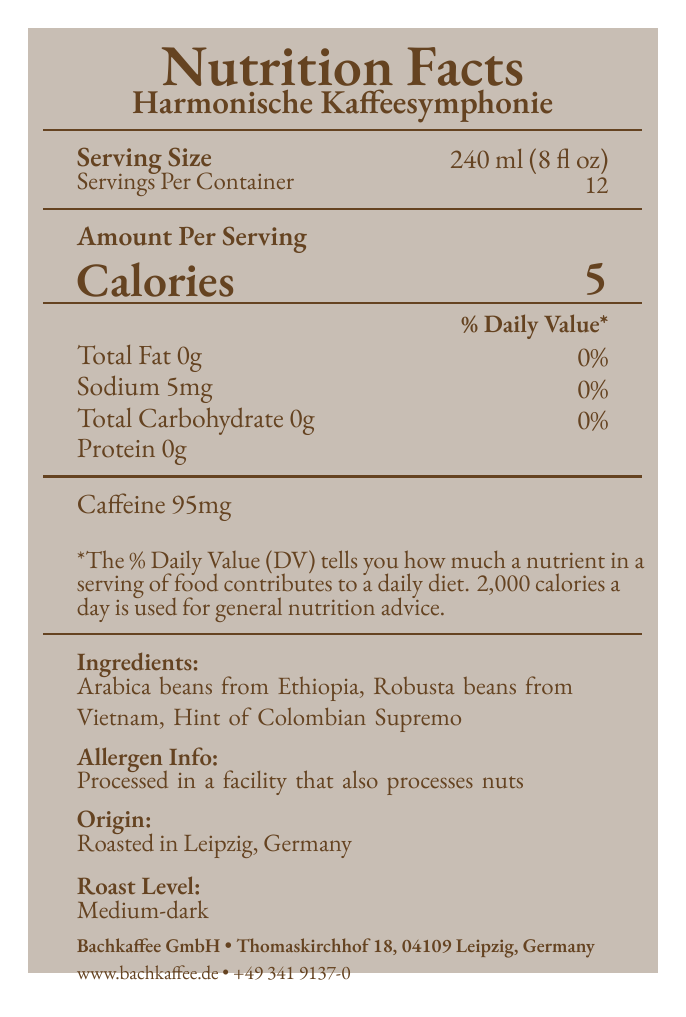what is the product name? The product name is listed at the top of the document under the "Nutrition Facts" header.
Answer: Harmonische Kaffeesymphonie how many calories are in one serving? The document indicates that there are 5 calories per serving.
Answer: 5 what is the serving size? The serving size is mentioned near the top of the document.
Answer: 240 ml (8 fl oz) how many servings are in one container? The document states that there are 12 servings per container.
Answer: 12 how much caffeine is in one serving? The caffeine content per serving is listed towards the bottom of the nutrition details.
Answer: 95 mg which ingredient is not listed in the blend? A. Arabica beans from Ethiopia B. Robusta beans from Vietnam C. Kona beans from Hawaii D. Colombian Supremo The ingredients listed are Arabica beans from Ethiopia, Robusta beans from Vietnam, and a hint of Colombian Supremo. Kona beans from Hawaii are not listed.
Answer: C. Kona beans from Hawaii where is this coffee roasted? A. Berlin, Germany B. Leipzig, Germany C. Vienna, Austria D. Hamburg, Germany The document indicates that the coffee is roasted in Leipzig, Germany.
Answer: B. Leipzig, Germany is the product certified organic? One of the certifications listed is "Organic".
Answer: Yes is this product suitable for someone with a nut allergy? The allergen info states that the product is processed in a facility that also processes nuts, which may not be safe for someone with a nut allergy.
Answer: No summarize the main details of this document. The document details the essential nutritional information, ingredients, certifications, processing information, and recommendations for usage and storage of the coffee blend, along with contact information for the company.
Answer: The document provides the nutritional facts for "Harmonische Kaffeesymphonie," a specialty coffee blend favored by classical music enthusiasts. Each serving is 240 ml (8 fl oz) with 5 calories and 95 mg of caffeine. The ingredients include Arabica beans from Ethiopia, Robusta beans from Vietnam, and a hint of Colombian Supremo. The coffee is roasted in Leipzig, Germany, and has a medium-dark roast level. The product is certified as Fair Trade, Organic, and Rainforest Alliance. It is processed in a facility that also processes nuts. Storage and brewing recommendations are provided, along with company contact information. how much sodium is in one serving? The sodium content per serving is listed as 5 mg.
Answer: 5 mg which flavor notes are associated with this coffee blend? The flavor notes section lists these three classical compositions alongside their corresponding flavors.
Answer: Beethoven's Symphony No. 5 (Dark Chocolate), Mozart's Eine kleine Nachtmusik (Caramel), Bach's Brandenburg Concertos (Citrus) what is the address of Bachkaffee GmbH? The company’s address is listed at the bottom of the document.
Answer: Thomaskirchhof 18, 04109 Leipzig, Germany is the daily value percentage of total fat higher than 0%? The daily value percentage for total fat is 0%.
Answer: No what are the storage instructions for this coffee? The storage instructions are listed towards the bottom of the document.
Answer: Store in a cool, dry place. Best consumed within 4 weeks of roasting date. what is the phone number for customer service? The customer service phone number is listed at the bottom of the document.
Answer: +49 341 9137-0 how many grams of protein are in one serving? The protein content per serving is listed as 0g.
Answer: 0g what is the primary reason people might choose this coffee blend according to the document? The document emphasizes the unique flavor notes tied to classical music, making it appealing to classical music enthusiasts.
Answer: The primary reason is that it is a specialty coffee blend favored by classical music enthusiasts, with specific flavor notes inspired by famous classical compositions. is there any information about the roasting date? The document does not specify any details about the roasting date itself; it notes storage instructions saying 'best consumed within 4 weeks of roasting date' without providing an actual date.
Answer: Not enough information 